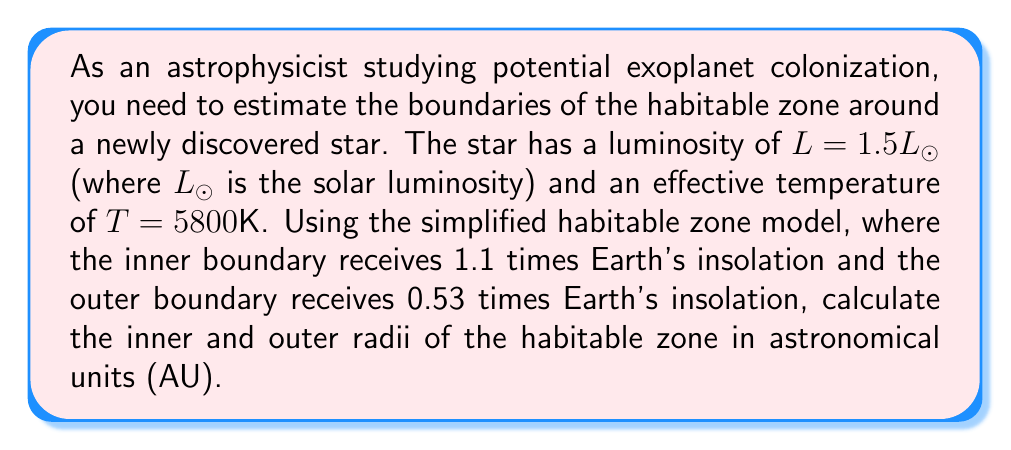Show me your answer to this math problem. To solve this problem, we'll use the following steps:

1) First, recall the relation between stellar luminosity ($L$), radius ($R$), and effective temperature ($T$):

   $$L = 4\pi R^2 \sigma T^4$$

   where $\sigma$ is the Stefan-Boltzmann constant.

2) We don't need to calculate the star's radius explicitly. Instead, we can use the fact that the insolation ($I$) at a distance $d$ from the star is given by:

   $$I = \frac{L}{4\pi d^2}$$

3) For the inner boundary of the habitable zone, we want $I = 1.1I_{\oplus}$, where $I_{\oplus}$ is Earth's insolation. For the outer boundary, we want $I = 0.53I_{\oplus}$.

4) We know that at Earth's distance from the Sun (1 AU), $I_{\oplus} = L_{\odot} / (4\pi \cdot 1^2 AU^2)$. 

5) For the inner boundary:

   $$1.1I_{\oplus} = \frac{1.5L_{\odot}}{4\pi d_{in}^2}$$

   Solving for $d_{in}$:

   $$d_{in} = \sqrt{\frac{1.5L_{\odot}}{4\pi \cdot 1.1I_{\oplus}}} = \sqrt{\frac{1.5}{1.1}} \approx 1.17 \text{ AU}$$

6) For the outer boundary:

   $$0.53I_{\oplus} = \frac{1.5L_{\odot}}{4\pi d_{out}^2}$$

   Solving for $d_{out}$:

   $$d_{out} = \sqrt{\frac{1.5L_{\odot}}{4\pi \cdot 0.53I_{\oplus}}} = \sqrt{\frac{1.5}{0.53}} \approx 1.68 \text{ AU}$$

Therefore, the habitable zone extends from approximately 1.17 AU to 1.68 AU from the star.
Answer: The inner boundary of the habitable zone is at 1.17 AU, and the outer boundary is at 1.68 AU from the star. 